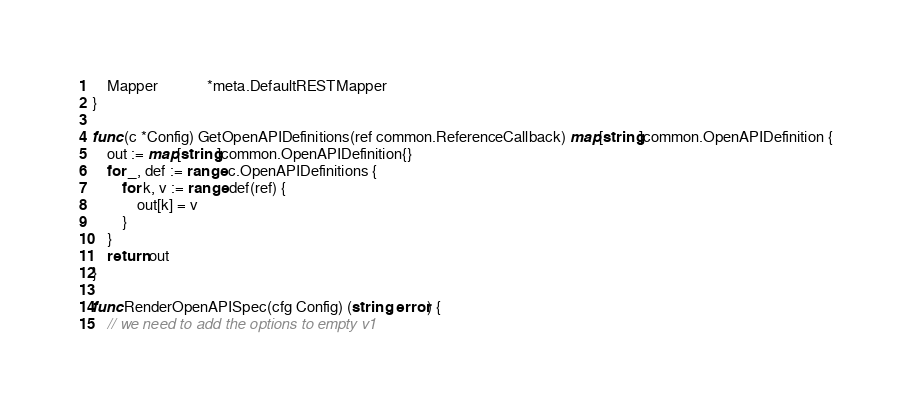<code> <loc_0><loc_0><loc_500><loc_500><_Go_>	Mapper             *meta.DefaultRESTMapper
}

func (c *Config) GetOpenAPIDefinitions(ref common.ReferenceCallback) map[string]common.OpenAPIDefinition {
	out := map[string]common.OpenAPIDefinition{}
	for _, def := range c.OpenAPIDefinitions {
		for k, v := range def(ref) {
			out[k] = v
		}
	}
	return out
}

func RenderOpenAPISpec(cfg Config) (string, error) {
	// we need to add the options to empty v1</code> 